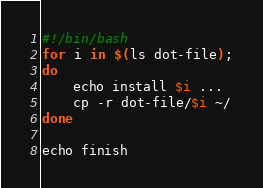<code> <loc_0><loc_0><loc_500><loc_500><_Bash_>#!/bin/bash
for i in $(ls dot-file);
do
	echo install $i ...
	cp -r dot-file/$i ~/
done

echo finish
</code> 